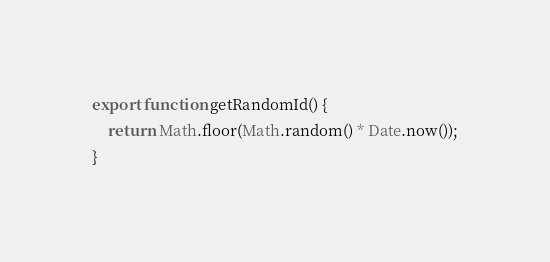<code> <loc_0><loc_0><loc_500><loc_500><_JavaScript_>export function getRandomId() {
    return Math.floor(Math.random() * Date.now());
}
</code> 